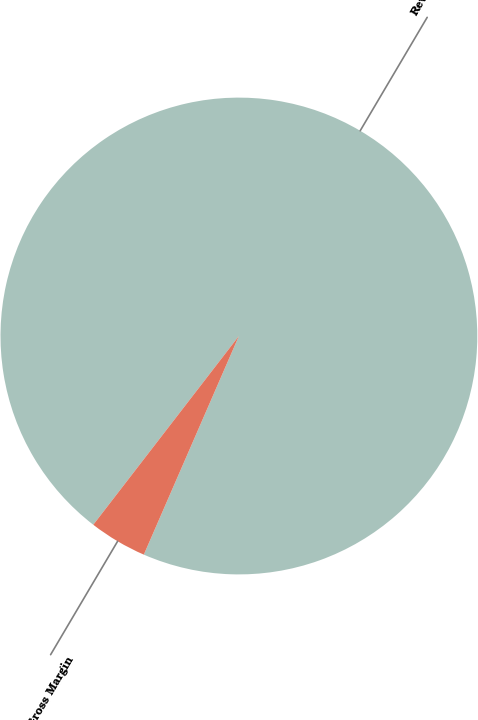Convert chart. <chart><loc_0><loc_0><loc_500><loc_500><pie_chart><fcel>Revenue<fcel>Gross Margin<nl><fcel>96.07%<fcel>3.93%<nl></chart> 